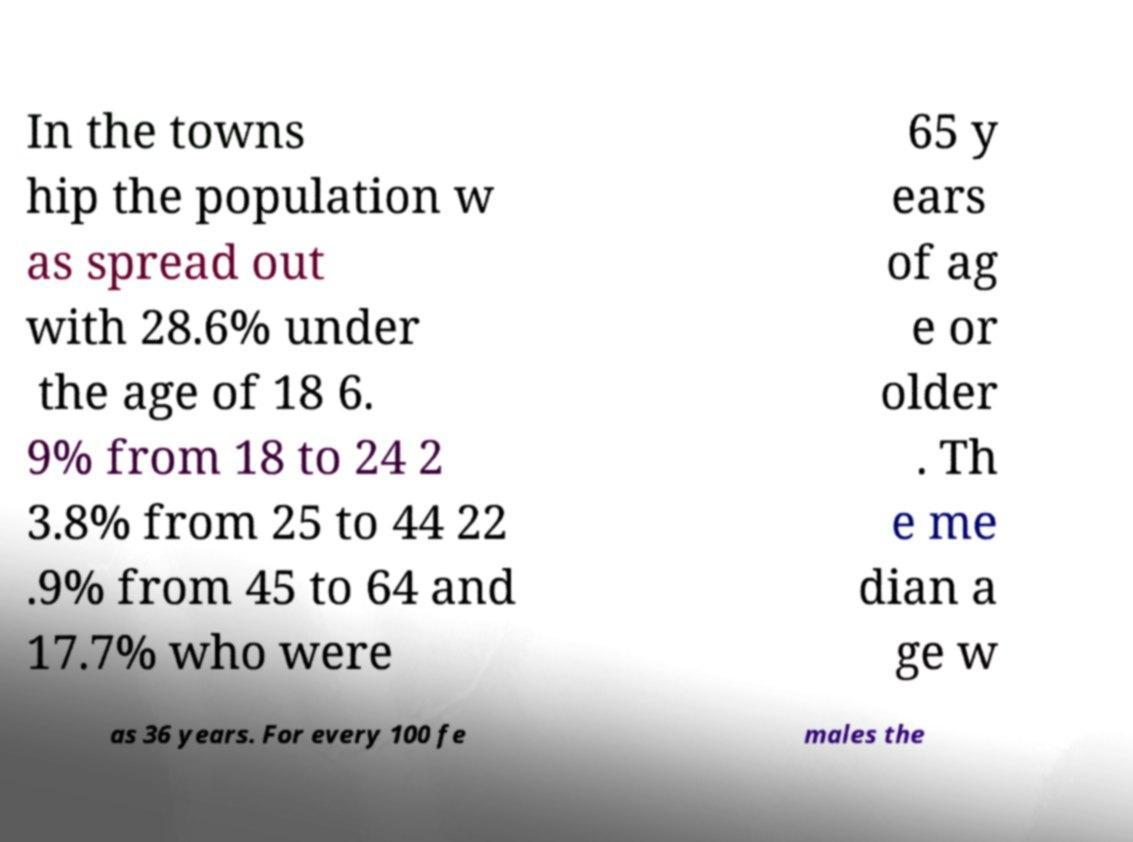Please identify and transcribe the text found in this image. In the towns hip the population w as spread out with 28.6% under the age of 18 6. 9% from 18 to 24 2 3.8% from 25 to 44 22 .9% from 45 to 64 and 17.7% who were 65 y ears of ag e or older . Th e me dian a ge w as 36 years. For every 100 fe males the 